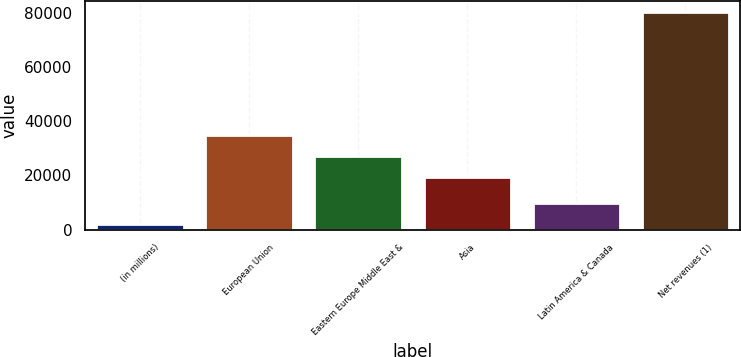Convert chart. <chart><loc_0><loc_0><loc_500><loc_500><bar_chart><fcel>(in millions)<fcel>European Union<fcel>Eastern Europe Middle East &<fcel>Asia<fcel>Latin America & Canada<fcel>Net revenues (1)<nl><fcel>2014<fcel>34873.4<fcel>27064.2<fcel>19255<fcel>9865<fcel>80106<nl></chart> 